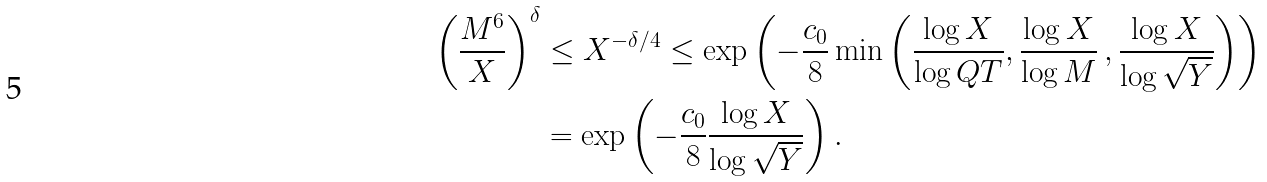Convert formula to latex. <formula><loc_0><loc_0><loc_500><loc_500>\left ( \frac { M ^ { 6 } } { X } \right ) ^ { \delta } & \leq X ^ { - \delta / 4 } \leq \exp \left ( - \frac { c _ { 0 } } { 8 } \min \left ( \frac { \log X } { \log Q T } , \frac { \log X } { \log M } \, , \frac { \log X } { \log \sqrt { Y } } \right ) \right ) \\ & = \exp \left ( - \frac { c _ { 0 } } { 8 } \frac { \log X } { \log \sqrt { Y } } \right ) .</formula> 